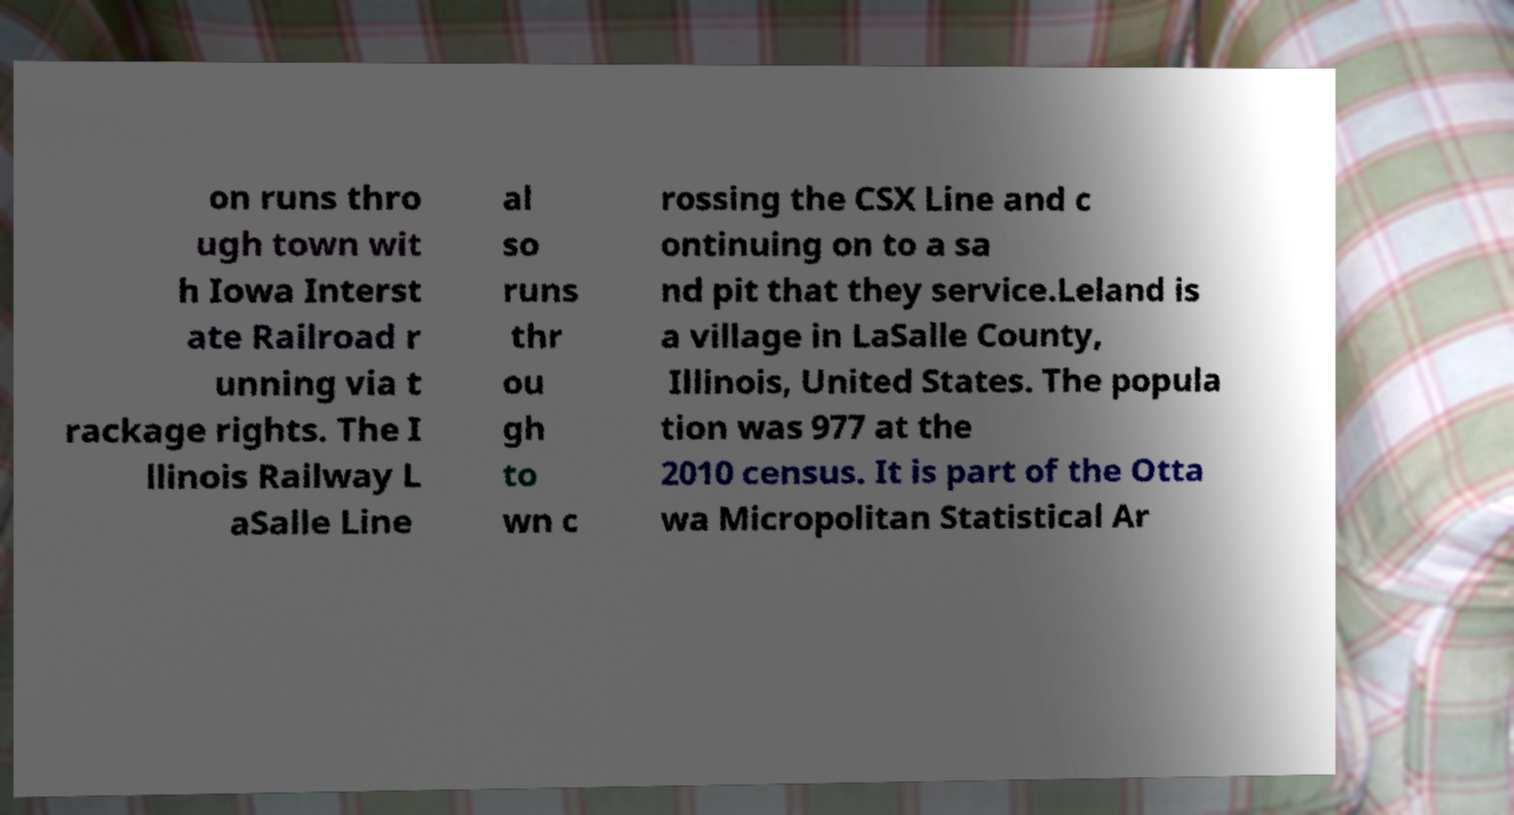There's text embedded in this image that I need extracted. Can you transcribe it verbatim? on runs thro ugh town wit h Iowa Interst ate Railroad r unning via t rackage rights. The I llinois Railway L aSalle Line al so runs thr ou gh to wn c rossing the CSX Line and c ontinuing on to a sa nd pit that they service.Leland is a village in LaSalle County, Illinois, United States. The popula tion was 977 at the 2010 census. It is part of the Otta wa Micropolitan Statistical Ar 